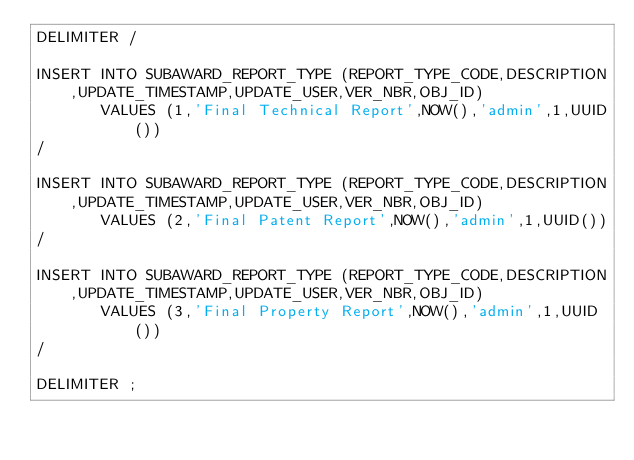<code> <loc_0><loc_0><loc_500><loc_500><_SQL_>DELIMITER /

INSERT INTO SUBAWARD_REPORT_TYPE (REPORT_TYPE_CODE,DESCRIPTION,UPDATE_TIMESTAMP,UPDATE_USER,VER_NBR,OBJ_ID)
       VALUES (1,'Final Technical Report',NOW(),'admin',1,UUID())
/

INSERT INTO SUBAWARD_REPORT_TYPE (REPORT_TYPE_CODE,DESCRIPTION,UPDATE_TIMESTAMP,UPDATE_USER,VER_NBR,OBJ_ID)
       VALUES (2,'Final Patent Report',NOW(),'admin',1,UUID())
/

INSERT INTO SUBAWARD_REPORT_TYPE (REPORT_TYPE_CODE,DESCRIPTION,UPDATE_TIMESTAMP,UPDATE_USER,VER_NBR,OBJ_ID)
       VALUES (3,'Final Property Report',NOW(),'admin',1,UUID())
/

DELIMITER ;</code> 